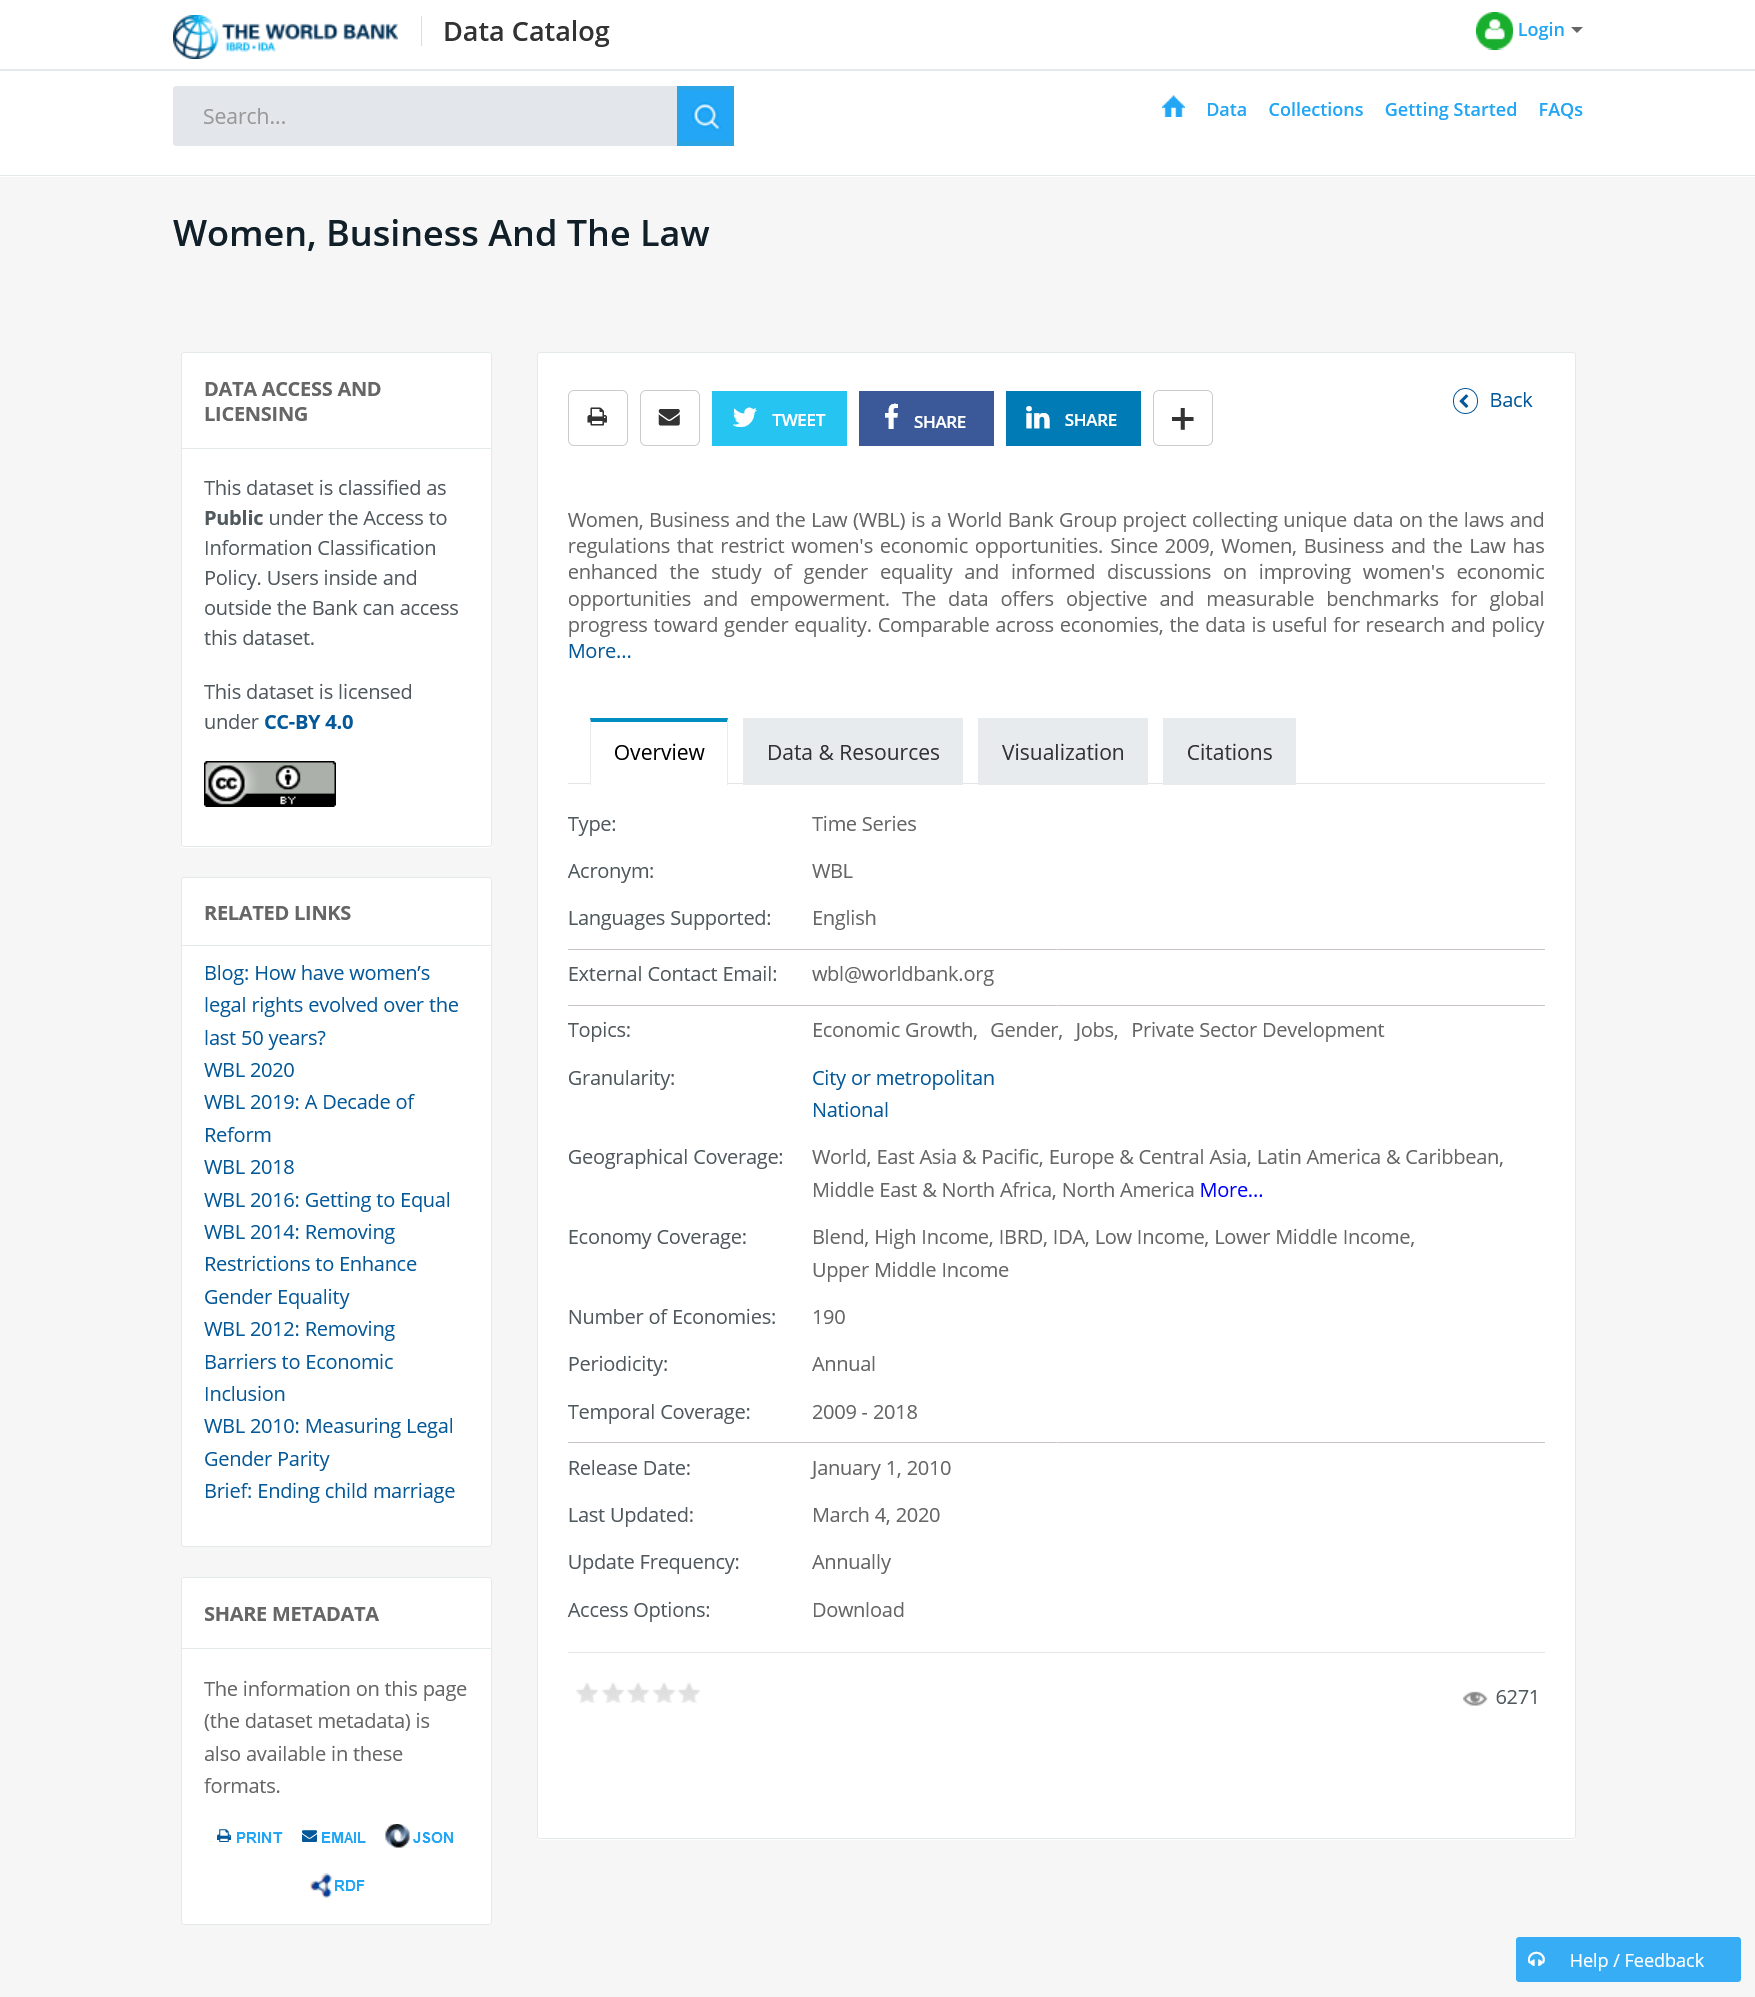List a handful of essential elements in this visual. This article can be shared on several social media platforms, including Twitter, Facebook, and Instagram. WBL stands for Women, Business, and the Law. This article is titled, 'Women, Business and the Law.' 